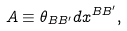Convert formula to latex. <formula><loc_0><loc_0><loc_500><loc_500>A \equiv \theta _ { B B ^ { \prime } } d x ^ { B B ^ { \prime } } ,</formula> 